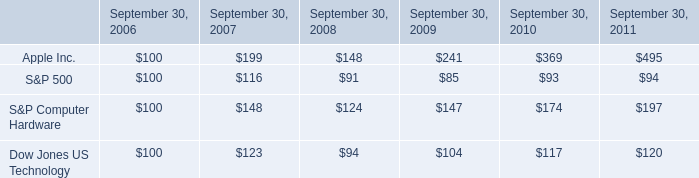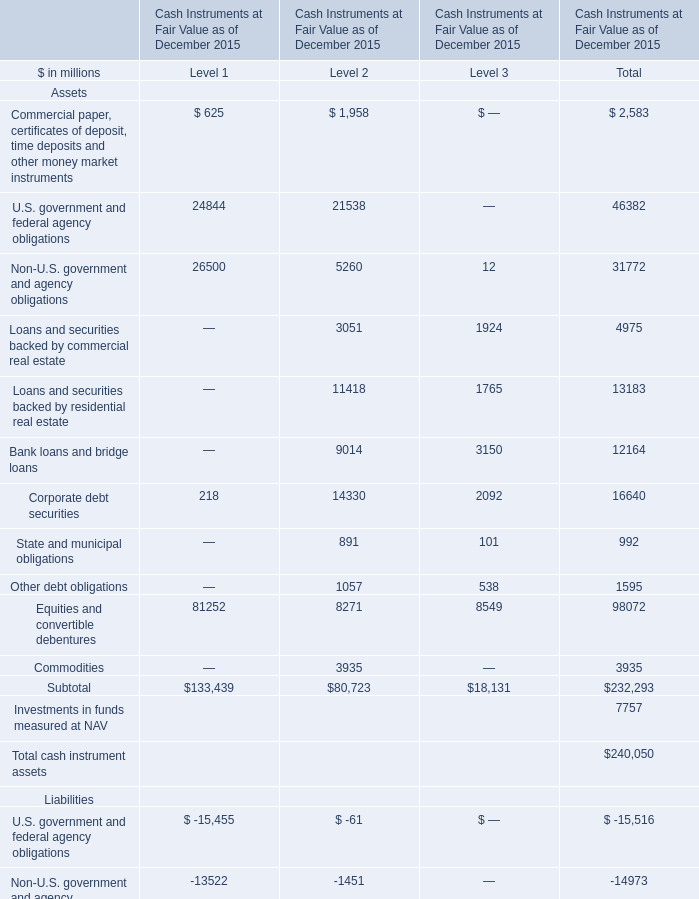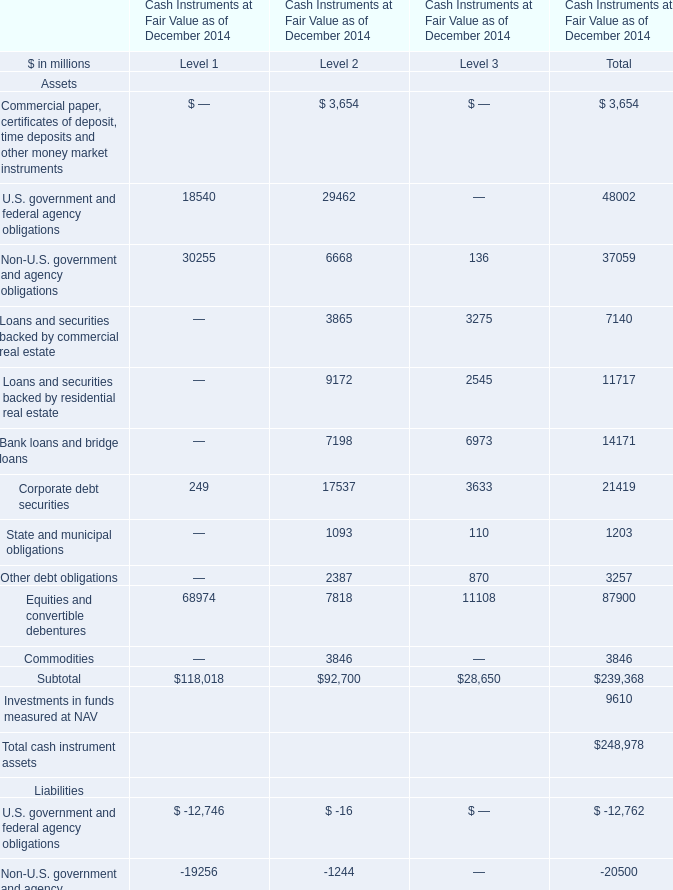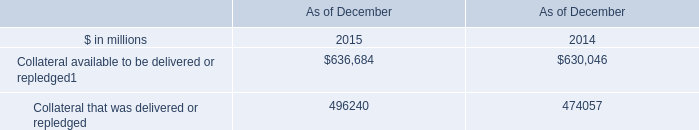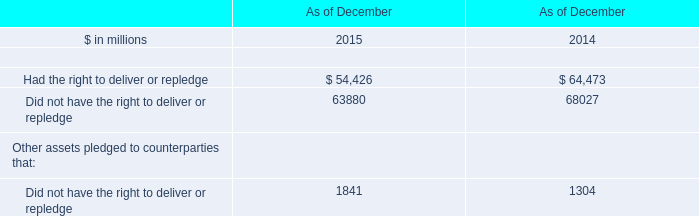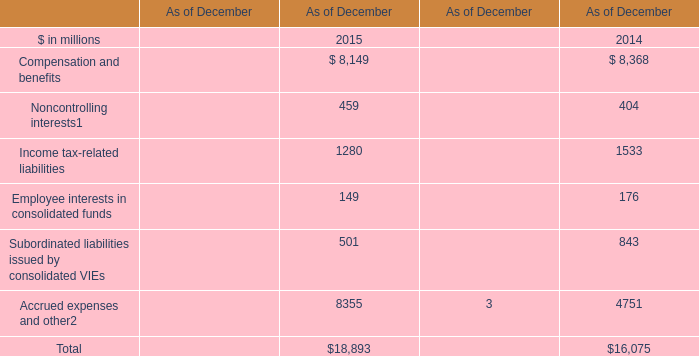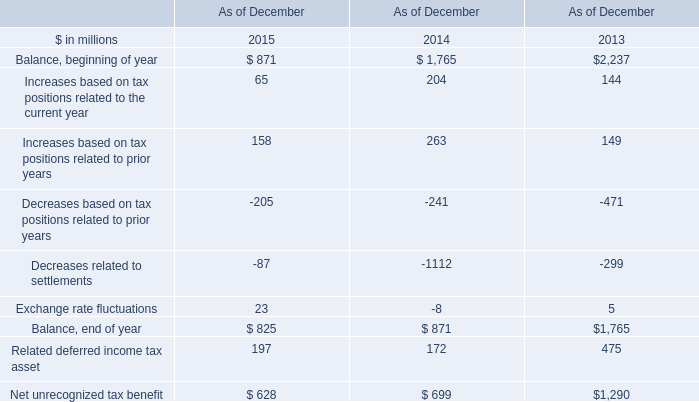What was the total amount of Commercial paper, certificates of deposit, time deposits and other money market instruments in 2015? (in million) 
Computations: (625 + 1958)
Answer: 2583.0. 